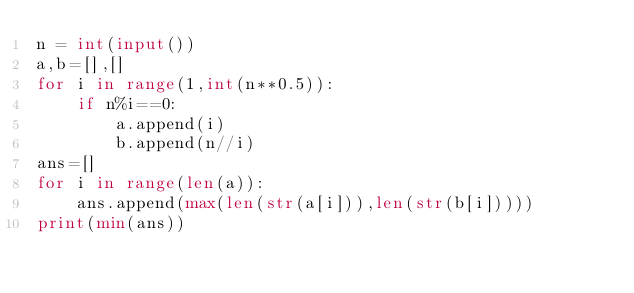<code> <loc_0><loc_0><loc_500><loc_500><_Python_>n = int(input())
a,b=[],[]
for i in range(1,int(n**0.5)):
    if n%i==0:
        a.append(i)
        b.append(n//i)
ans=[]
for i in range(len(a)):
    ans.append(max(len(str(a[i])),len(str(b[i]))))
print(min(ans))</code> 